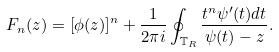Convert formula to latex. <formula><loc_0><loc_0><loc_500><loc_500>F _ { n } ( z ) = [ \phi ( z ) ] ^ { n } + \frac { 1 } { 2 \pi i } \oint _ { \mathbb { T } _ { R } } \frac { t ^ { n } \psi ^ { \prime } ( t ) d t } { \psi ( t ) - z } .</formula> 